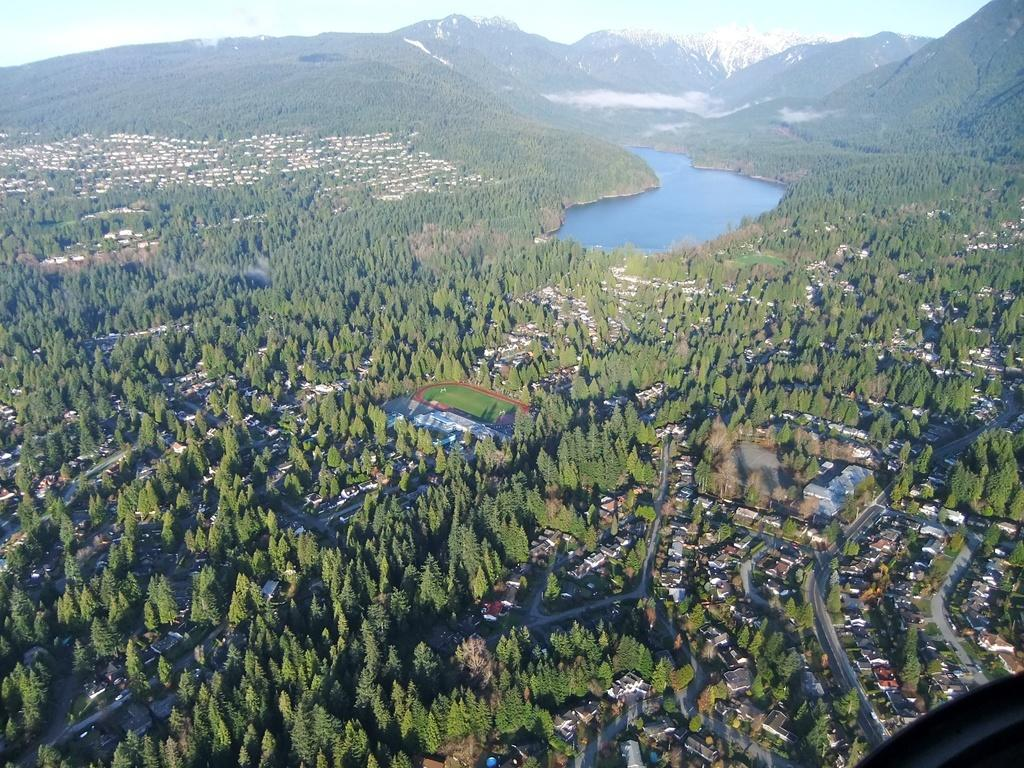What type of view is shown in the image? The image is an aerial view. What structures can be seen from this perspective? There are buildings visible in the image. What natural elements are present in the image? Trees, water, hills, and mountains are present in the image. What man-made features can be seen in the image? Roads are visible in the image. What part of the natural environment is visible in the image? The sky is visible in the image. What color is the shirt worn by the crow in the image? There is no crow or shirt present in the image. What phase of the moon can be seen in the image? The image does not show the moon; it is an aerial view of a landscape. 